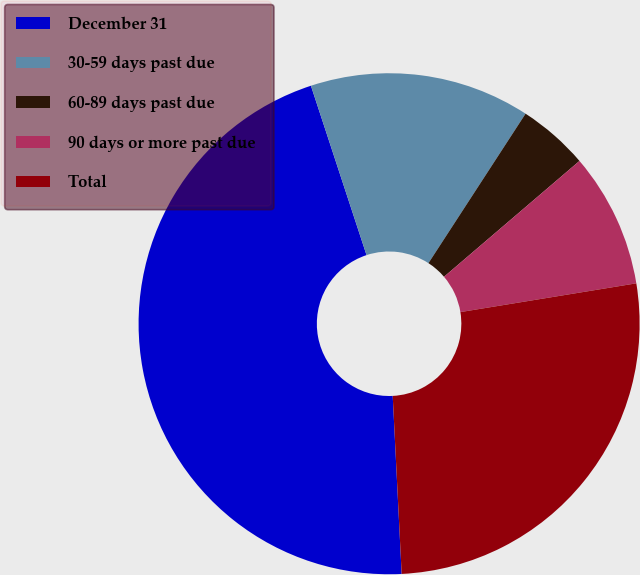<chart> <loc_0><loc_0><loc_500><loc_500><pie_chart><fcel>December 31<fcel>30-59 days past due<fcel>60-89 days past due<fcel>90 days or more past due<fcel>Total<nl><fcel>45.75%<fcel>14.22%<fcel>4.57%<fcel>8.68%<fcel>26.78%<nl></chart> 